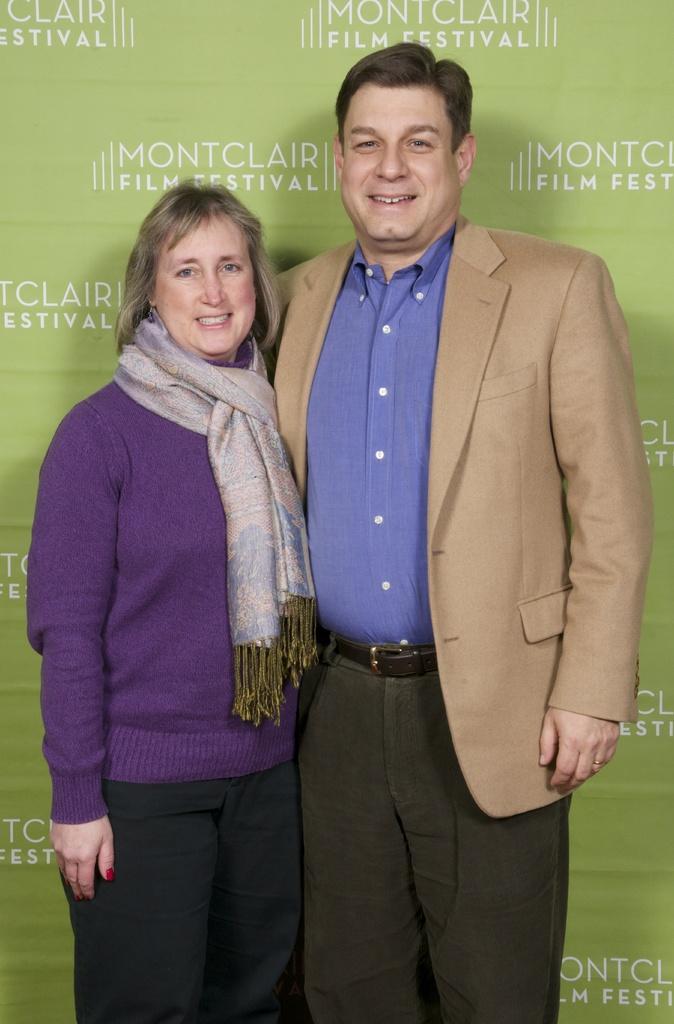Can you describe this image briefly? In this picture there is a man who is wearing suit, shirt and trouser. Beside him there is a woman who is wearing scarf, t-shirt and trouser. In the back there is a banner. 